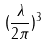<formula> <loc_0><loc_0><loc_500><loc_500>( \frac { \lambda } { 2 \pi } ) ^ { 3 }</formula> 